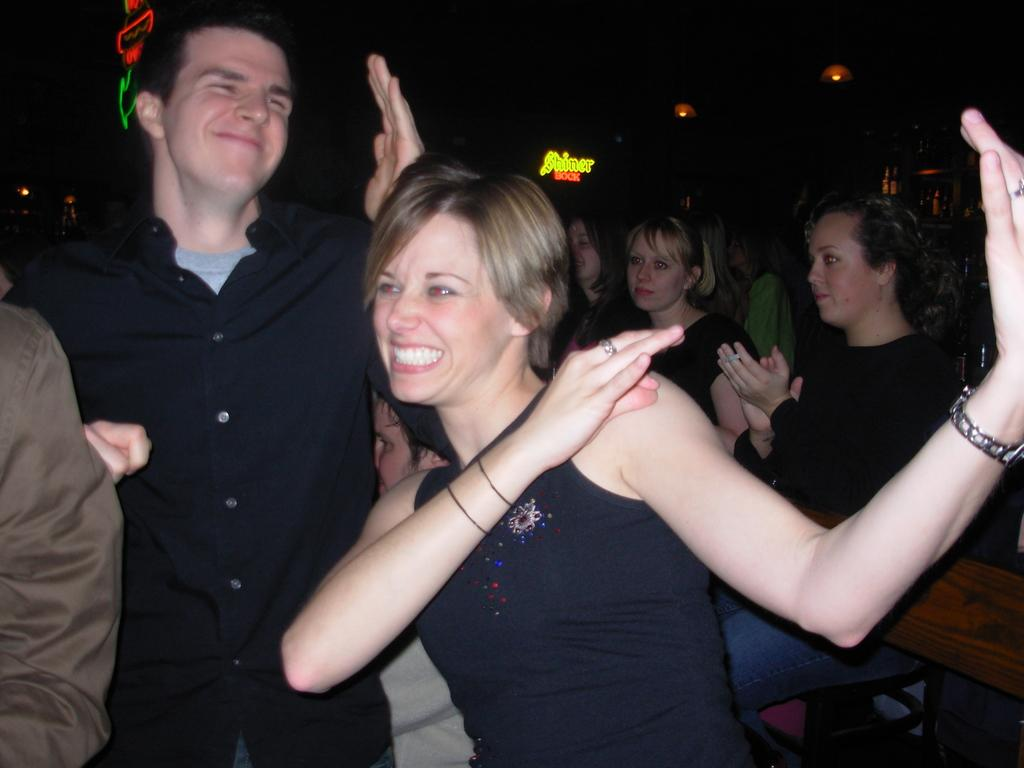How many people are in the image? The number of people in the image is not specified, but there are people present. What is the color of the background in the image? The background of the image is dark. What can be seen illuminating the scene in the image? There are lights visible in the image. What type of objects are present in the image? There are boards present in the image. What type of offer is being made by the people in the image? There is no indication in the image that the people are making any offers. Can you tell me how many times the people in the image have printed something? There is no information about printing in the image. 